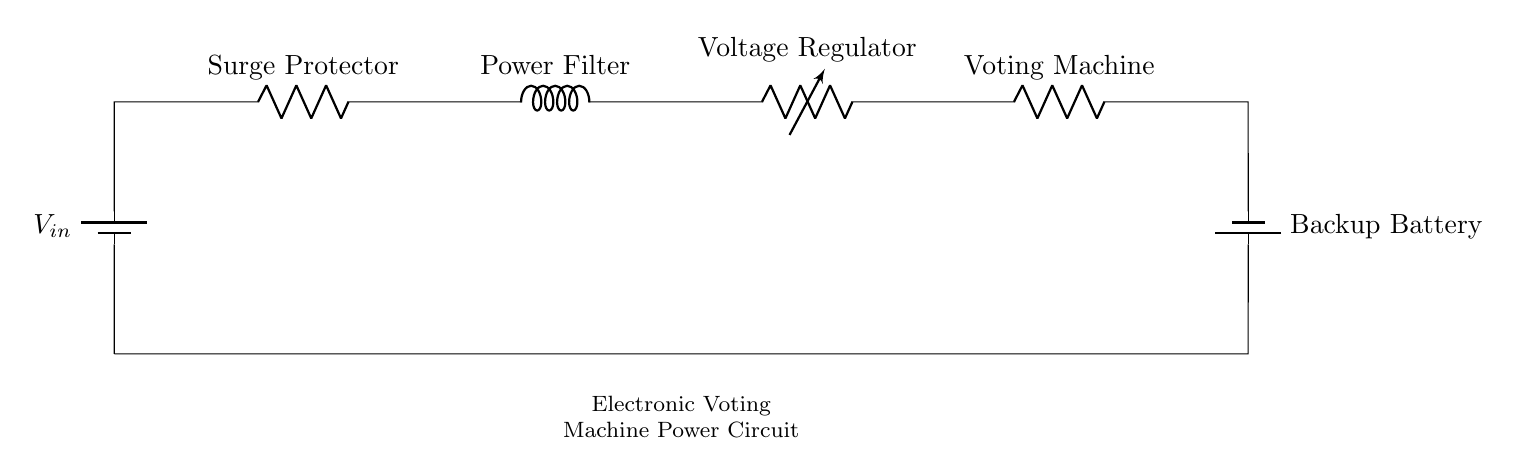What is the first component in the circuit? The first component as indicated in the schematic is the battery, which provides the input voltage to the circuit.
Answer: battery How many resistors are present in the circuit? There are two resistors in the circuit: one labeled as a surge protector and the other as a voting machine, as shown in the diagram.
Answer: 2 What is the purpose of the voltage regulator? The voltage regulator's role is to maintain a consistent output voltage to the voting machine, ensuring it operates within specified voltage limits.
Answer: consistent output voltage What is connected after the power filter? The voltage regulator is connected immediately after the power filter, as seen in the diagram, indicating the sequence of components in the series circuit.
Answer: voltage regulator If the input voltage is 12 volts, what is the primary function of the components in the circuit? The components collectively function to ensure that the voting machine receives a stable and protected power supply, protecting it from voltage fluctuations.
Answer: stable power supply What component provides backup power? The backup battery is connected to ensure that the voting machines remain powered during an outage or failure to the main power source.
Answer: backup battery What type of circuit is illustrated in the diagram? The circuit is a series circuit, meaning all components are connected end-to-end, allowing current to flow through each component in sequence.
Answer: series circuit 